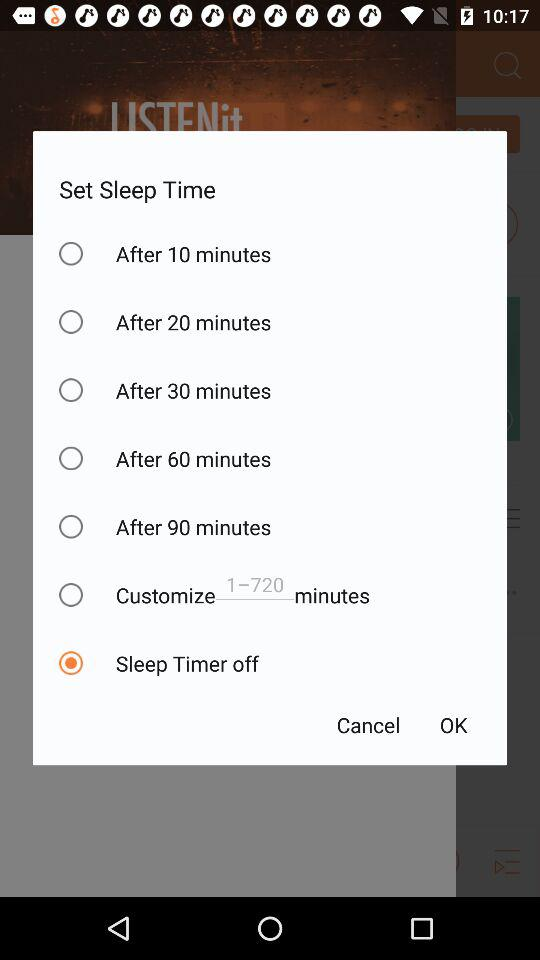Which option is selected for sleep time? The selected option is "Sleep Timer off". 